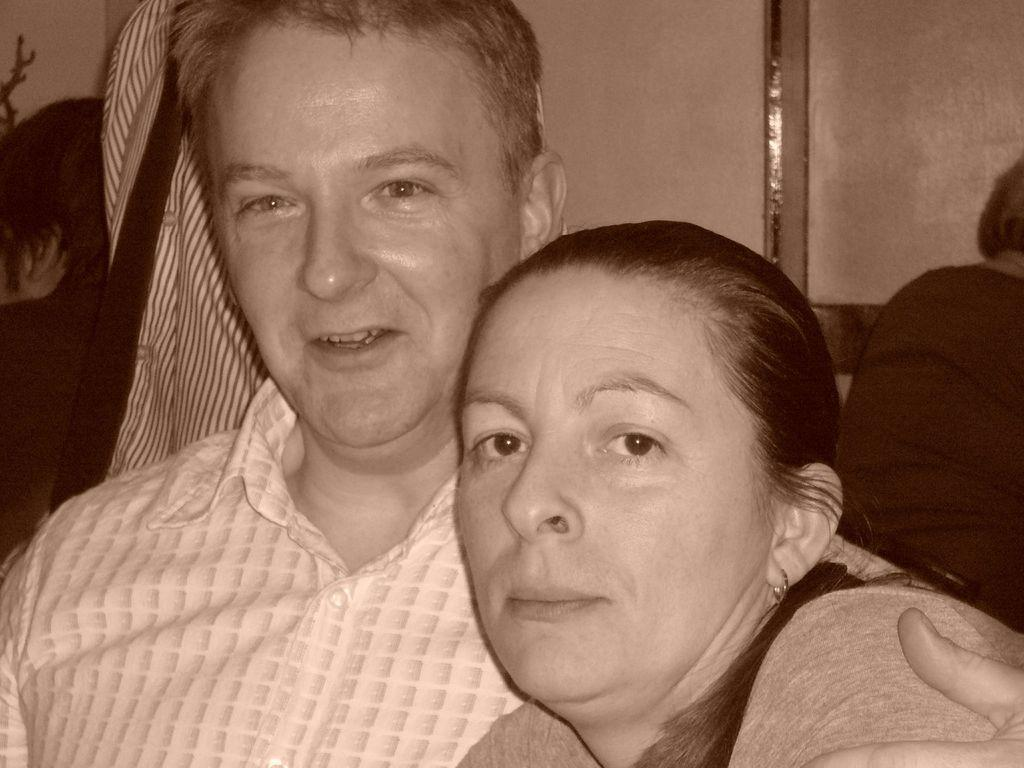How many people are present in the image? There are 2 people in the image. Can you describe the position of the third person in the image? There is another person on the right side of the image. What type of soap is the person on the right side of the image using? There is no soap present in the image, as it features people and does not mention any soap-related activities. 